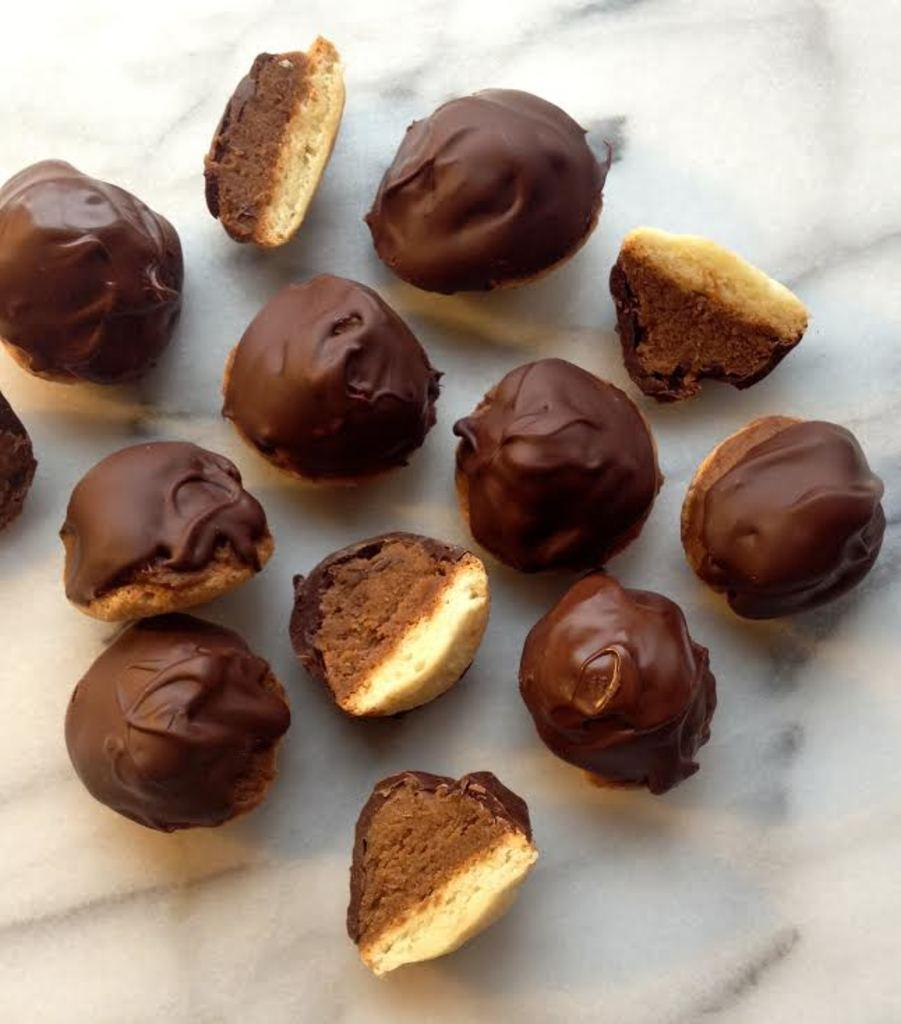What type of objects can be seen in the image? There are food items in the image. What is the color of the surface on which the food items are placed? The food items are on a white surface. How much does the mist weigh in the image? There is no mist present in the image, so it is not possible to determine its weight. 